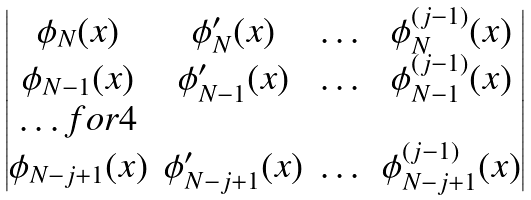Convert formula to latex. <formula><loc_0><loc_0><loc_500><loc_500>\begin{vmatrix} \phi _ { N } ( x ) & \phi ^ { \prime } _ { N } ( x ) & \dots & \phi _ { N } ^ { ( j - 1 ) } ( x ) \\ \phi _ { N - 1 } ( x ) & \phi ^ { \prime } _ { N - 1 } ( x ) & \dots & \phi _ { N - 1 } ^ { ( j - 1 ) } ( x ) \\ \hdots f o r { 4 } \\ \phi _ { N - j + 1 } ( x ) & \phi ^ { \prime } _ { N - j + 1 } ( x ) & \dots & \phi _ { N - j + 1 } ^ { ( j - 1 ) } ( x ) \\ \end{vmatrix}</formula> 